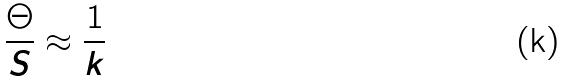<formula> <loc_0><loc_0><loc_500><loc_500>\frac { \Theta } { S } \approx \frac { 1 } { k }</formula> 